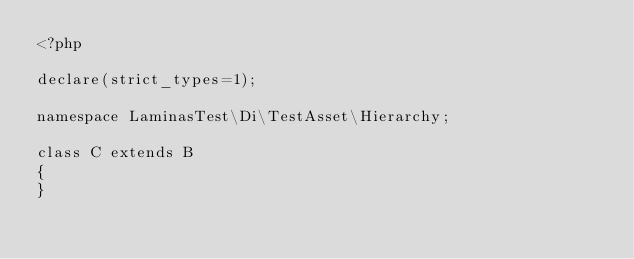Convert code to text. <code><loc_0><loc_0><loc_500><loc_500><_PHP_><?php

declare(strict_types=1);

namespace LaminasTest\Di\TestAsset\Hierarchy;

class C extends B
{
}
</code> 